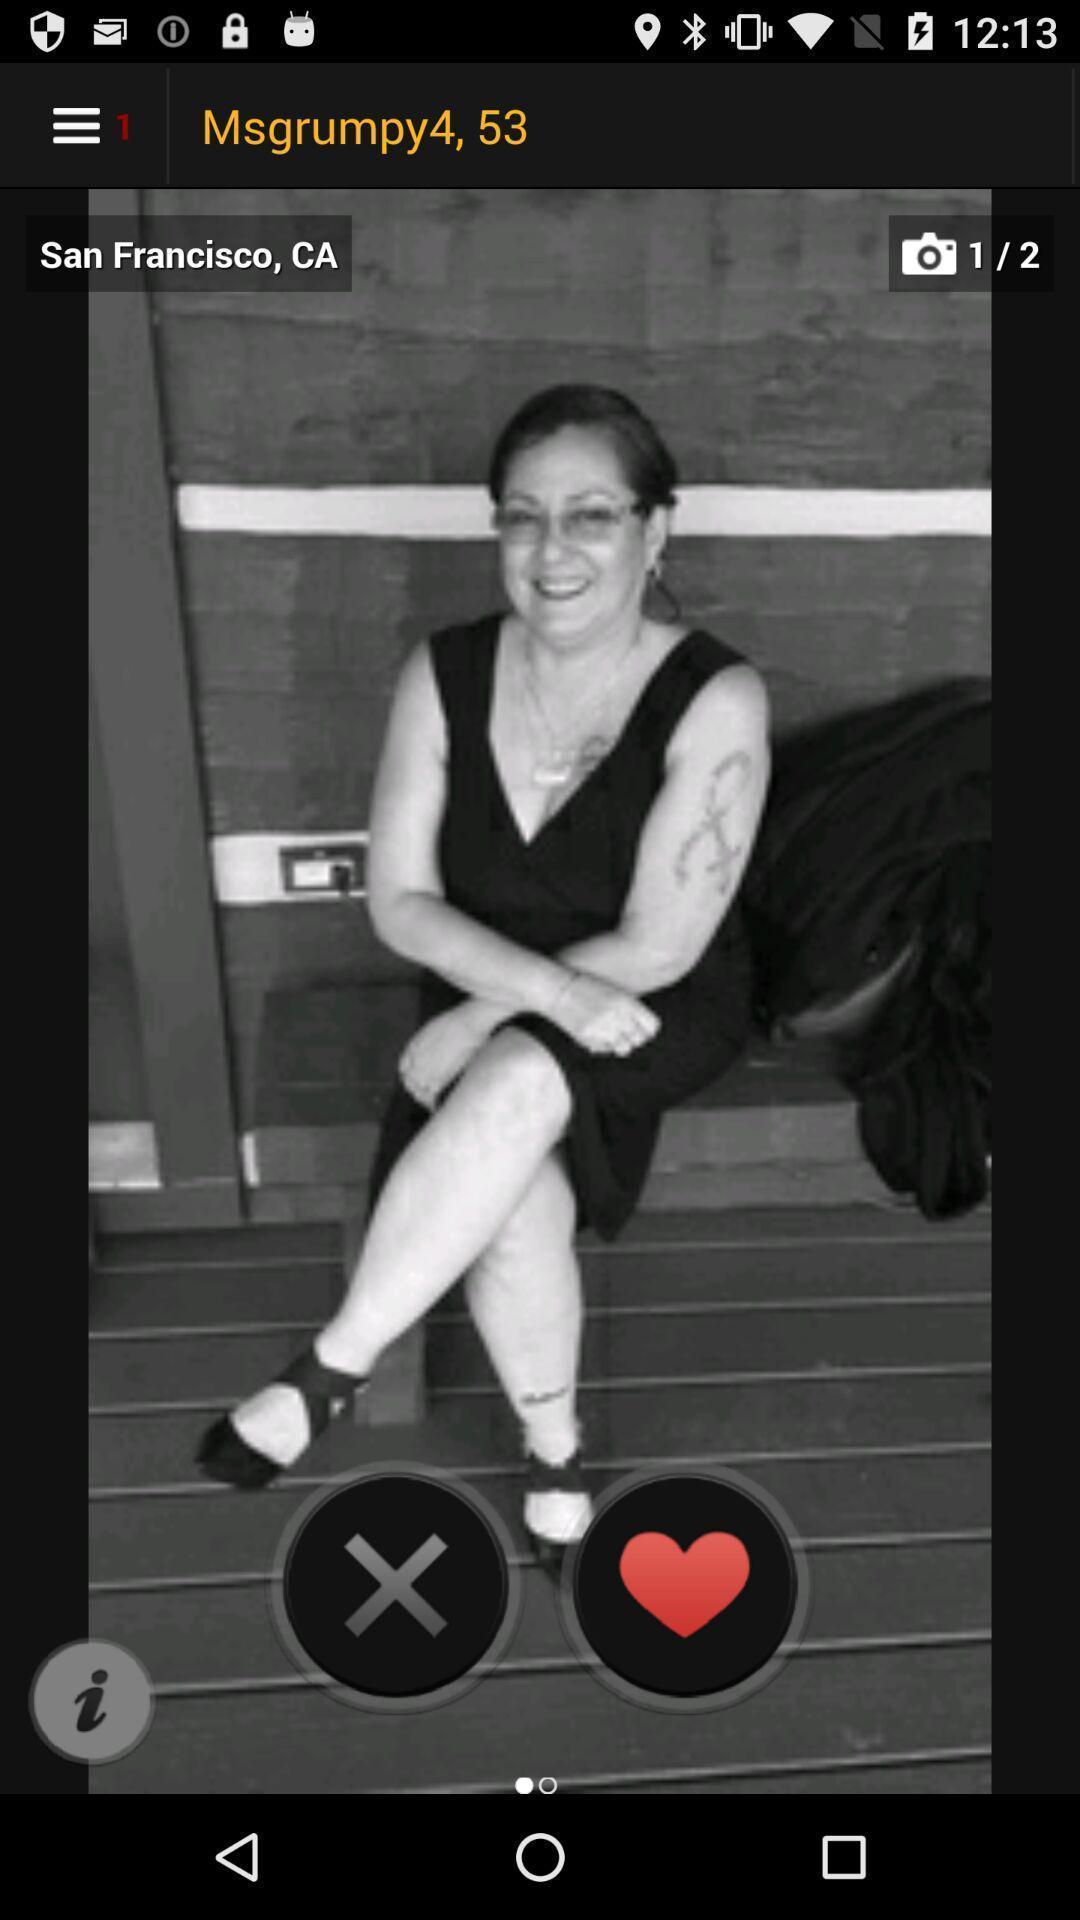Describe this image in words. Page displaying the profile of a woman. 